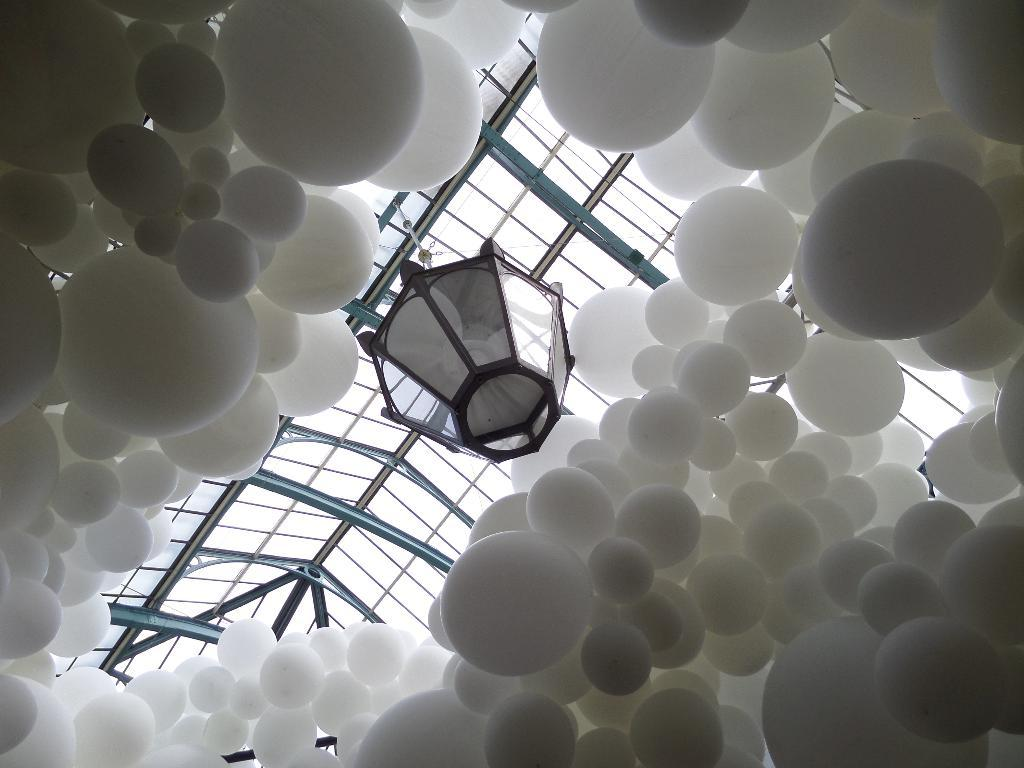What object can be seen in the image that provides light? There is a lamp in the image that provides light. How is the lamp secured in the image? The lamp is tied to a rope. What decorative items are present around the lamp? There are white color balloons around the lamp. What part of a building can be seen at the top of the image? There is a roof visible at the top of the image. What type of office furniture can be seen in the image? There is no office furniture present in the image; it features a lamp tied to a rope with white balloons around it. How many turkeys are visible in the image? There are no turkeys present in the image. 